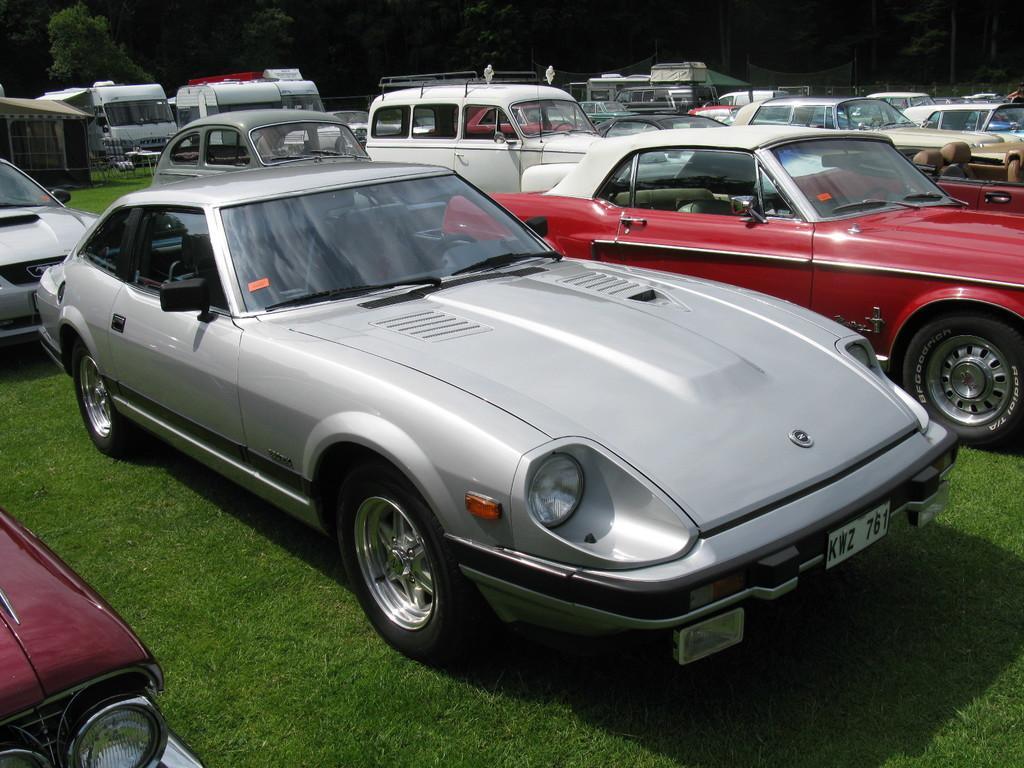In one or two sentences, can you explain what this image depicts? The picture consists of many cars, the cars are of different colors. In the background there are vans and trees. At the bottom there is grass. 